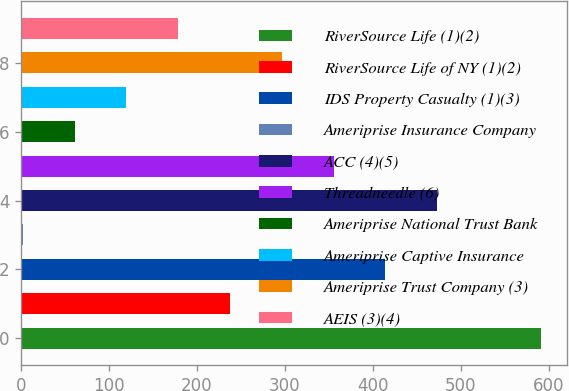Convert chart. <chart><loc_0><loc_0><loc_500><loc_500><bar_chart><fcel>RiverSource Life (1)(2)<fcel>RiverSource Life of NY (1)(2)<fcel>IDS Property Casualty (1)(3)<fcel>Ameriprise Insurance Company<fcel>ACC (4)(5)<fcel>Threadneedle (6)<fcel>Ameriprise National Trust Bank<fcel>Ameriprise Captive Insurance<fcel>Ameriprise Trust Company (3)<fcel>AEIS (3)(4)<nl><fcel>591<fcel>237.6<fcel>414.3<fcel>2<fcel>473.2<fcel>355.4<fcel>60.9<fcel>119.8<fcel>296.5<fcel>178.7<nl></chart> 